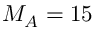<formula> <loc_0><loc_0><loc_500><loc_500>M _ { A } = 1 5</formula> 